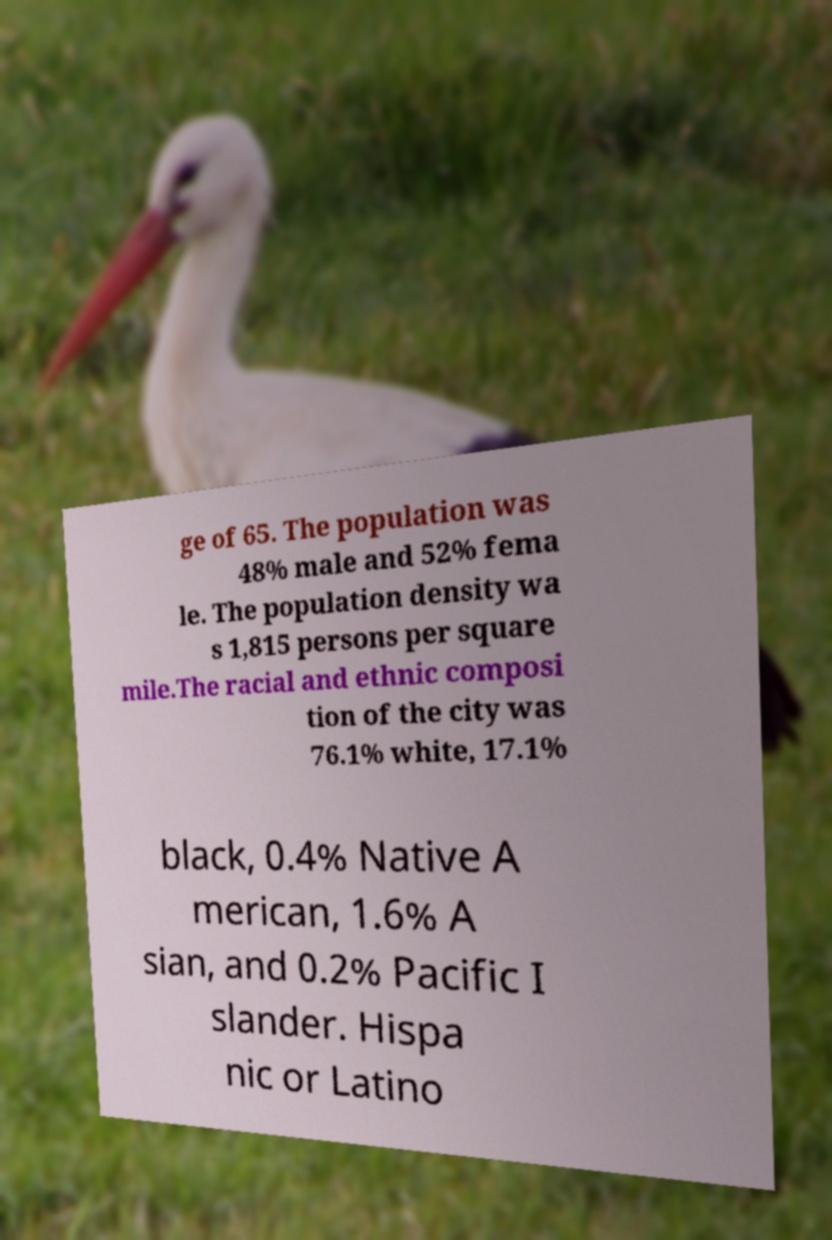There's text embedded in this image that I need extracted. Can you transcribe it verbatim? ge of 65. The population was 48% male and 52% fema le. The population density wa s 1,815 persons per square mile.The racial and ethnic composi tion of the city was 76.1% white, 17.1% black, 0.4% Native A merican, 1.6% A sian, and 0.2% Pacific I slander. Hispa nic or Latino 